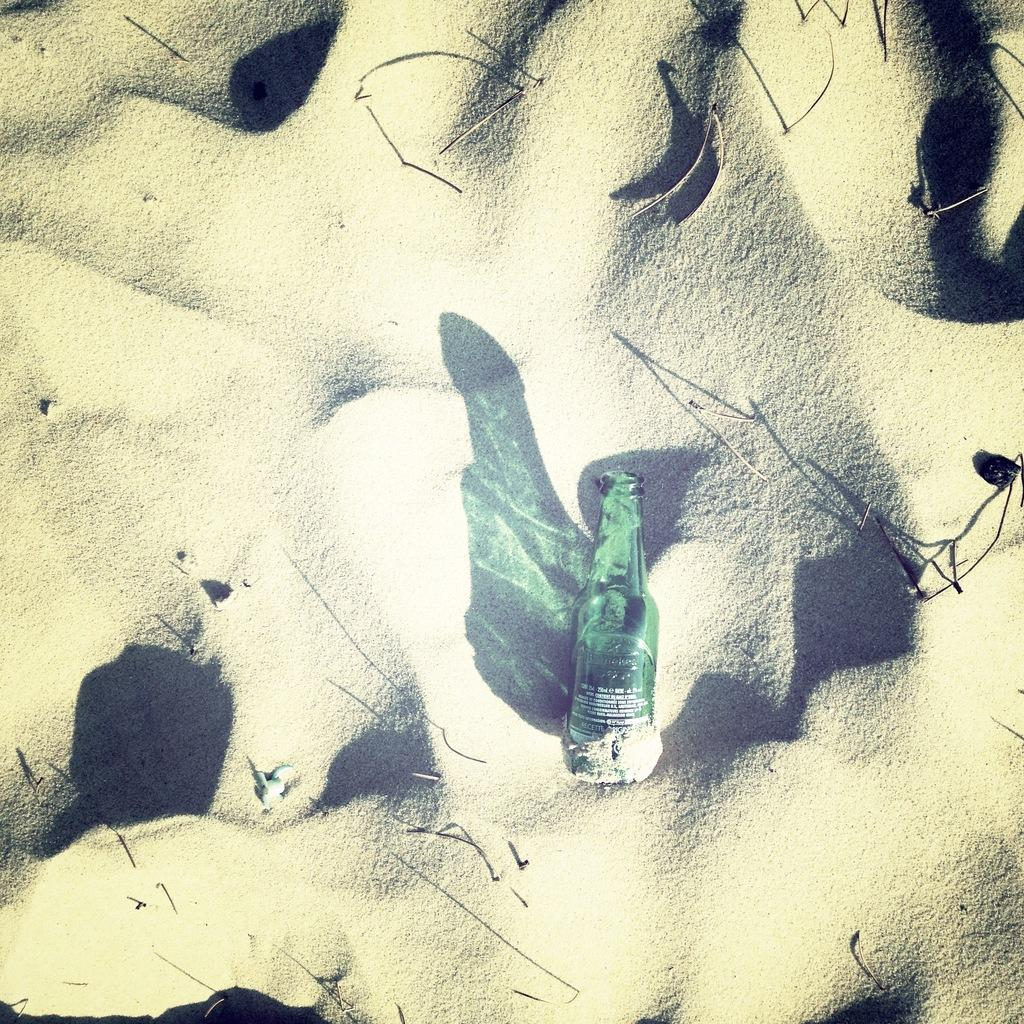What object can be seen in the image? There is a bottle in the image. Where is the bottle located? The bottle is on sand. Can you describe any additional features related to the bottle? There is a shadow associated with the bottle. What type of news can be seen coming from the frog in the image? There is no frog present in the image, so it is not possible to determine what type of news might be coming from a frog. 